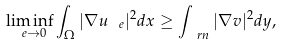Convert formula to latex. <formula><loc_0><loc_0><loc_500><loc_500>\liminf _ { \ e \to 0 } \int _ { \Omega } | \nabla u _ { \ e } | ^ { 2 } d x \geq \int _ { \ r n } | \nabla v | ^ { 2 } d y ,</formula> 